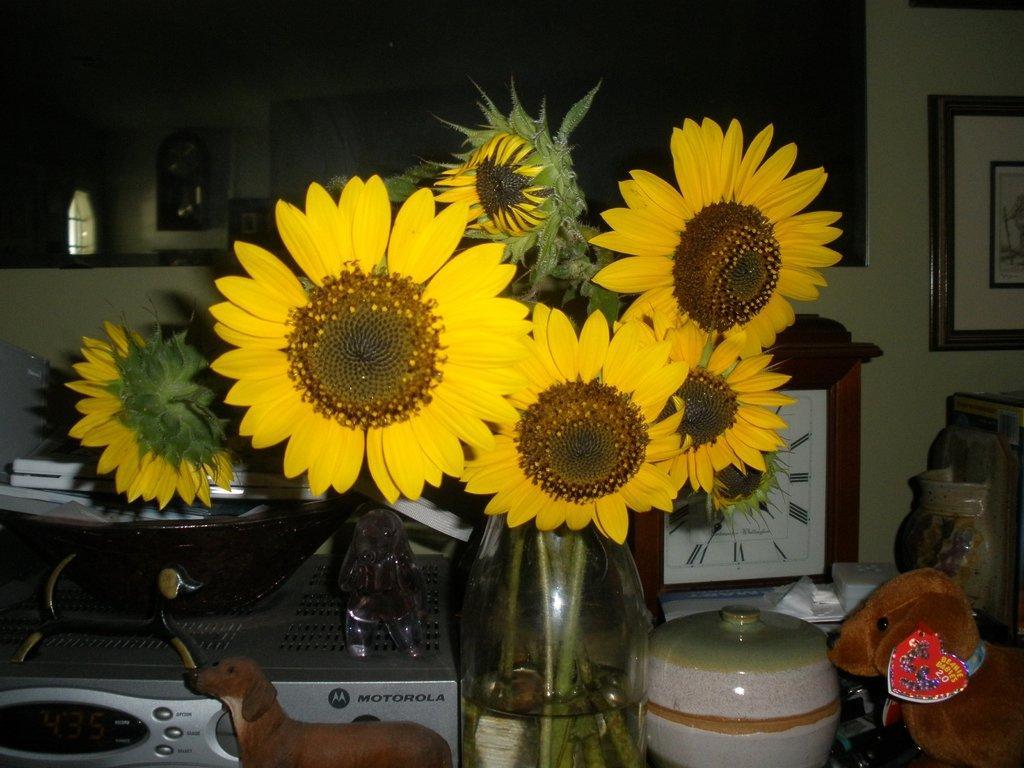Please provide a concise description of this image. On the background we can see window, Frame over a wall. Here on the table we can see a flower vase, dolls, a device, clock and a pot. 